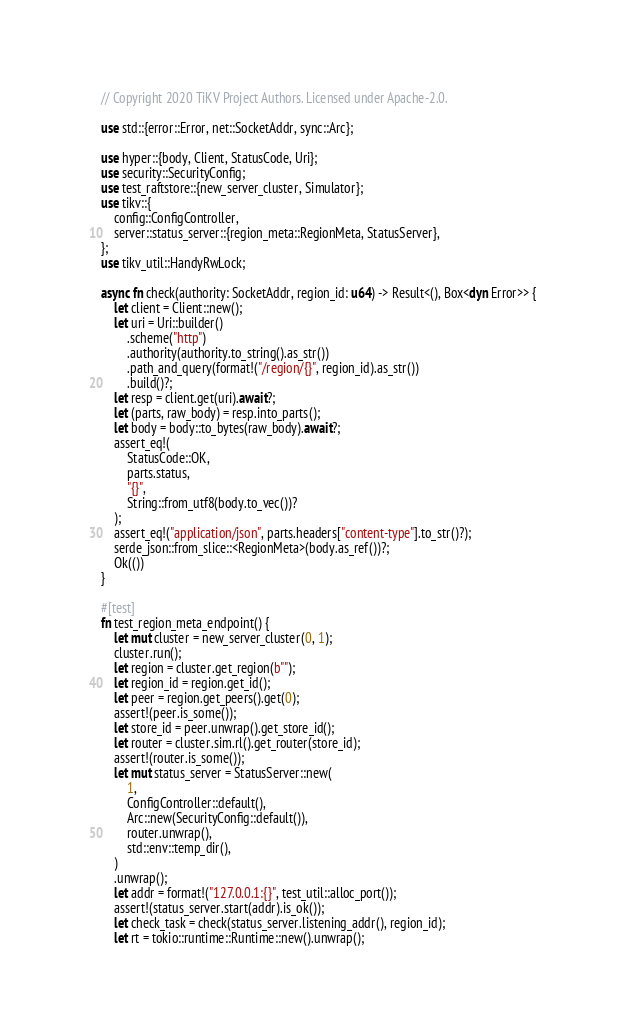Convert code to text. <code><loc_0><loc_0><loc_500><loc_500><_Rust_>// Copyright 2020 TiKV Project Authors. Licensed under Apache-2.0.

use std::{error::Error, net::SocketAddr, sync::Arc};

use hyper::{body, Client, StatusCode, Uri};
use security::SecurityConfig;
use test_raftstore::{new_server_cluster, Simulator};
use tikv::{
    config::ConfigController,
    server::status_server::{region_meta::RegionMeta, StatusServer},
};
use tikv_util::HandyRwLock;

async fn check(authority: SocketAddr, region_id: u64) -> Result<(), Box<dyn Error>> {
    let client = Client::new();
    let uri = Uri::builder()
        .scheme("http")
        .authority(authority.to_string().as_str())
        .path_and_query(format!("/region/{}", region_id).as_str())
        .build()?;
    let resp = client.get(uri).await?;
    let (parts, raw_body) = resp.into_parts();
    let body = body::to_bytes(raw_body).await?;
    assert_eq!(
        StatusCode::OK,
        parts.status,
        "{}",
        String::from_utf8(body.to_vec())?
    );
    assert_eq!("application/json", parts.headers["content-type"].to_str()?);
    serde_json::from_slice::<RegionMeta>(body.as_ref())?;
    Ok(())
}

#[test]
fn test_region_meta_endpoint() {
    let mut cluster = new_server_cluster(0, 1);
    cluster.run();
    let region = cluster.get_region(b"");
    let region_id = region.get_id();
    let peer = region.get_peers().get(0);
    assert!(peer.is_some());
    let store_id = peer.unwrap().get_store_id();
    let router = cluster.sim.rl().get_router(store_id);
    assert!(router.is_some());
    let mut status_server = StatusServer::new(
        1,
        ConfigController::default(),
        Arc::new(SecurityConfig::default()),
        router.unwrap(),
        std::env::temp_dir(),
    )
    .unwrap();
    let addr = format!("127.0.0.1:{}", test_util::alloc_port());
    assert!(status_server.start(addr).is_ok());
    let check_task = check(status_server.listening_addr(), region_id);
    let rt = tokio::runtime::Runtime::new().unwrap();</code> 